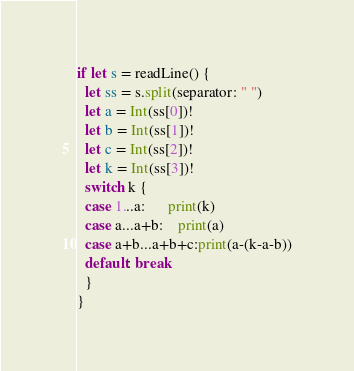Convert code to text. <code><loc_0><loc_0><loc_500><loc_500><_Swift_>if let s = readLine() {
  let ss = s.split(separator: " ")
  let a = Int(ss[0])!
  let b = Int(ss[1])!
  let c = Int(ss[2])!
  let k = Int(ss[3])!
  switch k {
  case 1...a:      print(k)
  case a...a+b:    print(a)
  case a+b...a+b+c:print(a-(k-a-b))
  default: break
  }
}</code> 